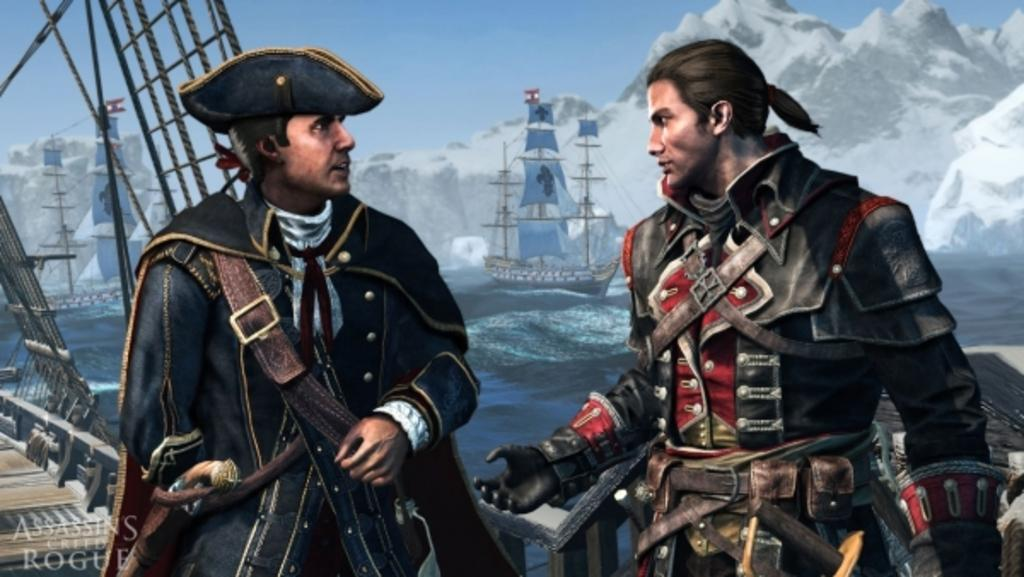How many people are in the image? There are two people in the image. What structure can be seen in the image? There is a bridge in the image. What mode of transportation is present in the image? There is a boat in the image. What type of landscape can be seen in the image? There are hills in the image. What is visible at the top of the image? The sky is visible at the top of the image. How many snakes are slithering on the bridge in the image? There are no snakes present in the image; it features a bridge, a boat, hills, and two people. What type of print can be seen on the boat in the image? There is no print visible on the boat in the image. 